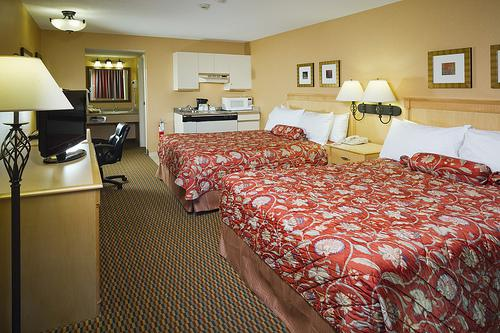Question: where was this photo taken?
Choices:
A. Bedroom.
B. Kitchen.
C. Basement.
D. Hotel room.
Answer with the letter. Answer: D Question: what color is the microwave?
Choices:
A. Black.
B. Red.
C. Silver.
D. White.
Answer with the letter. Answer: D Question: how many beds are shown?
Choices:
A. 3.
B. 2.
C. 1.
D. 4.
Answer with the letter. Answer: B Question: what is on?
Choices:
A. The television.
B. The microwave.
C. The lamps.
D. The toaster.
Answer with the letter. Answer: C Question: what has a red floral pattern?
Choices:
A. The drapes.
B. The couch cushions.
C. The rug.
D. The bedding.
Answer with the letter. Answer: D 